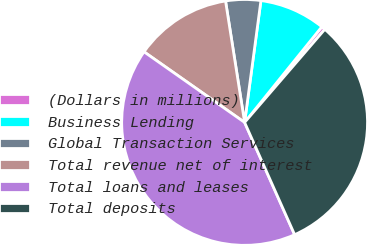<chart> <loc_0><loc_0><loc_500><loc_500><pie_chart><fcel>(Dollars in millions)<fcel>Business Lending<fcel>Global Transaction Services<fcel>Total revenue net of interest<fcel>Total loans and leases<fcel>Total deposits<nl><fcel>0.51%<fcel>8.69%<fcel>4.6%<fcel>12.78%<fcel>41.41%<fcel>32.01%<nl></chart> 